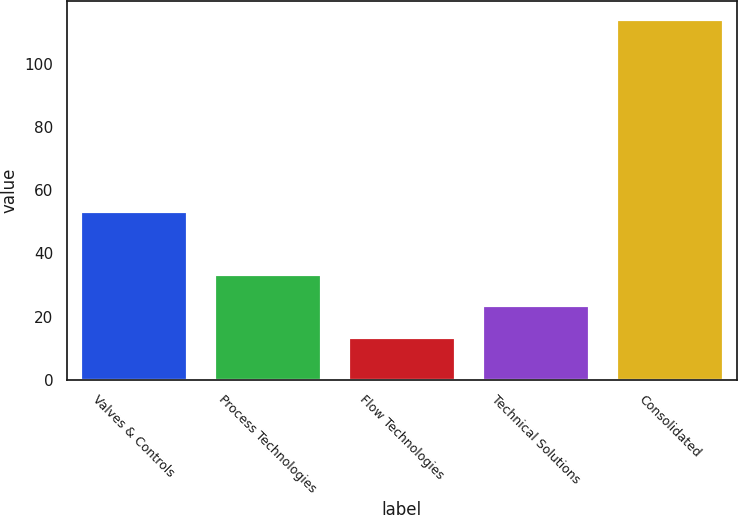Convert chart. <chart><loc_0><loc_0><loc_500><loc_500><bar_chart><fcel>Valves & Controls<fcel>Process Technologies<fcel>Flow Technologies<fcel>Technical Solutions<fcel>Consolidated<nl><fcel>53.4<fcel>33.6<fcel>13.5<fcel>23.55<fcel>114<nl></chart> 